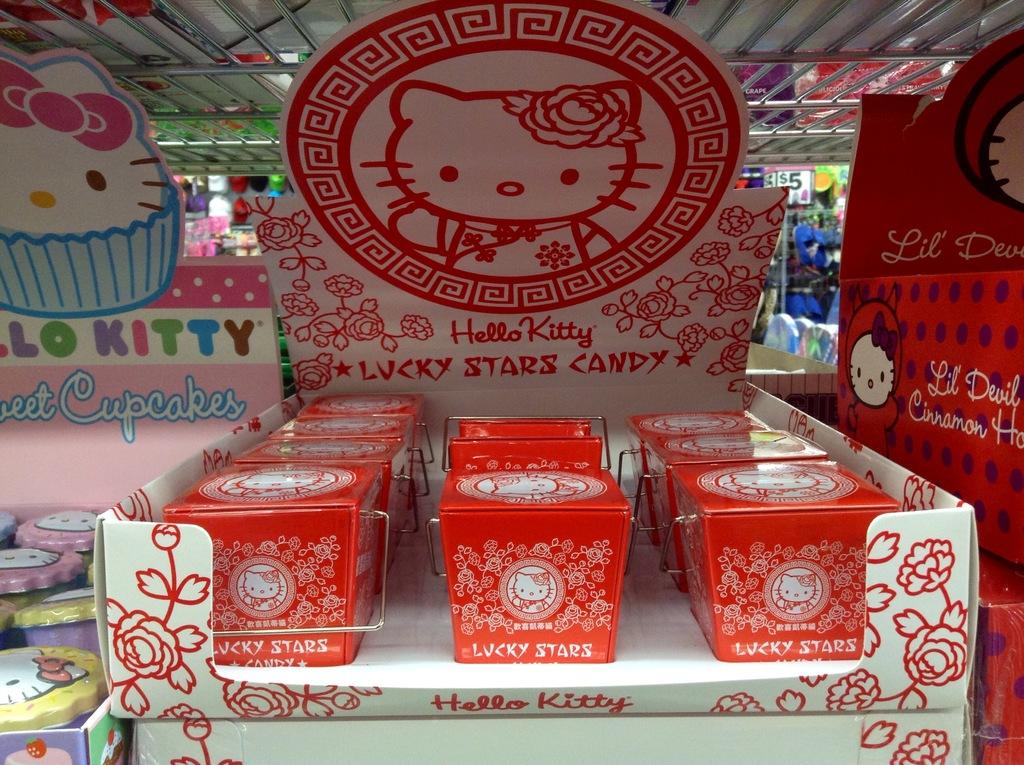Provide a one-sentence caption for the provided image. A display of Hello Kitty products are on a table. 